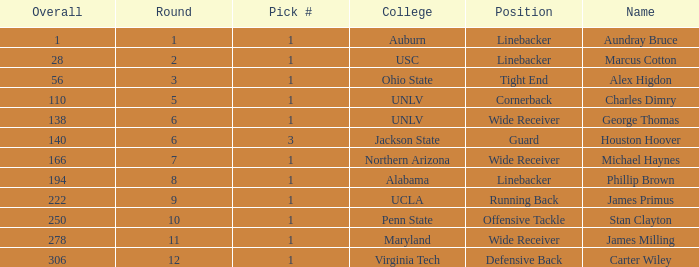What was the first Round with a Pick # greater than 1 and 140 Overall? None. 